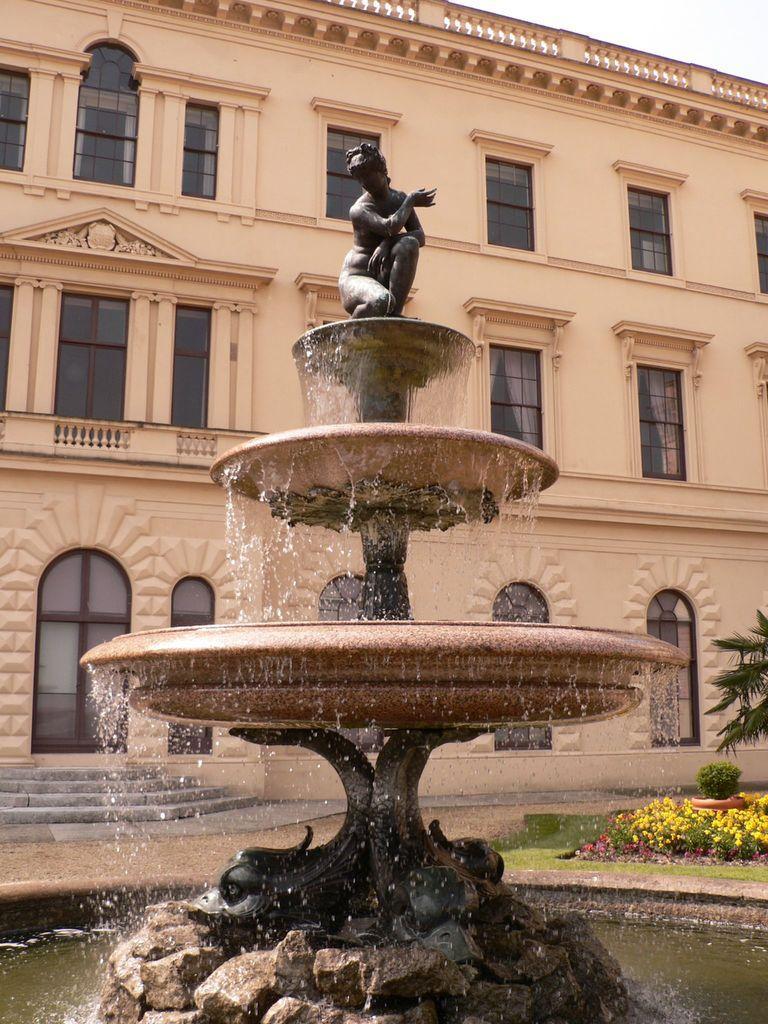How would you summarize this image in a sentence or two? In this image we can see fountain. Also there is water. And there are rocks. On the top of the fountain there is a statue. In the back there is a building with windows. On the right side there are flowering plants and branches of tree. 